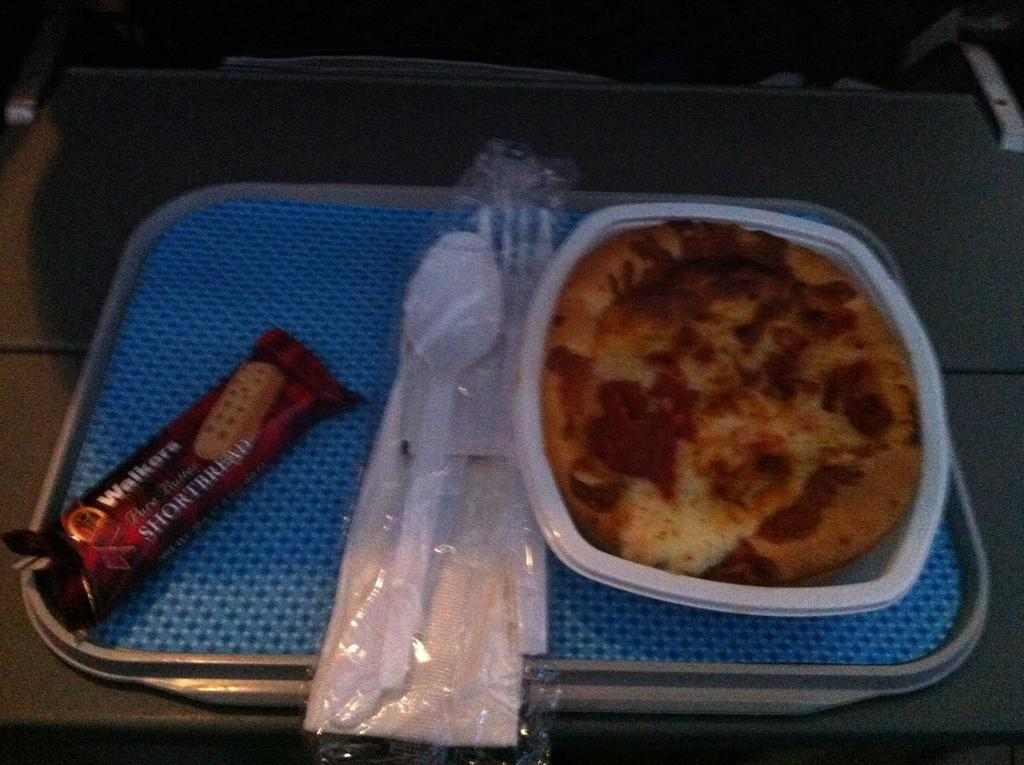What type of food is in the box in the image? The specific type of food in the box is not mentioned, but there is food in a box in the image. What utensils are visible in the image? There is a spoon and a fork in the image. What item might be used for wiping or drying in the image? There is a napkin in the image for wiping or drying. What is in the tray in the image? There is a cookie in a tray in the image. Where is the scene in the image set? The image appears to be set on a table. What type of polish is being applied to the writer's nails in the image? There is no writer or nail polish present in the image; it features food, utensils, and a napkin on a table. How does the slip affect the cookie's position in the tray in the image? There is no slip present in the image, and the cookie's position in the tray remains unchanged. 